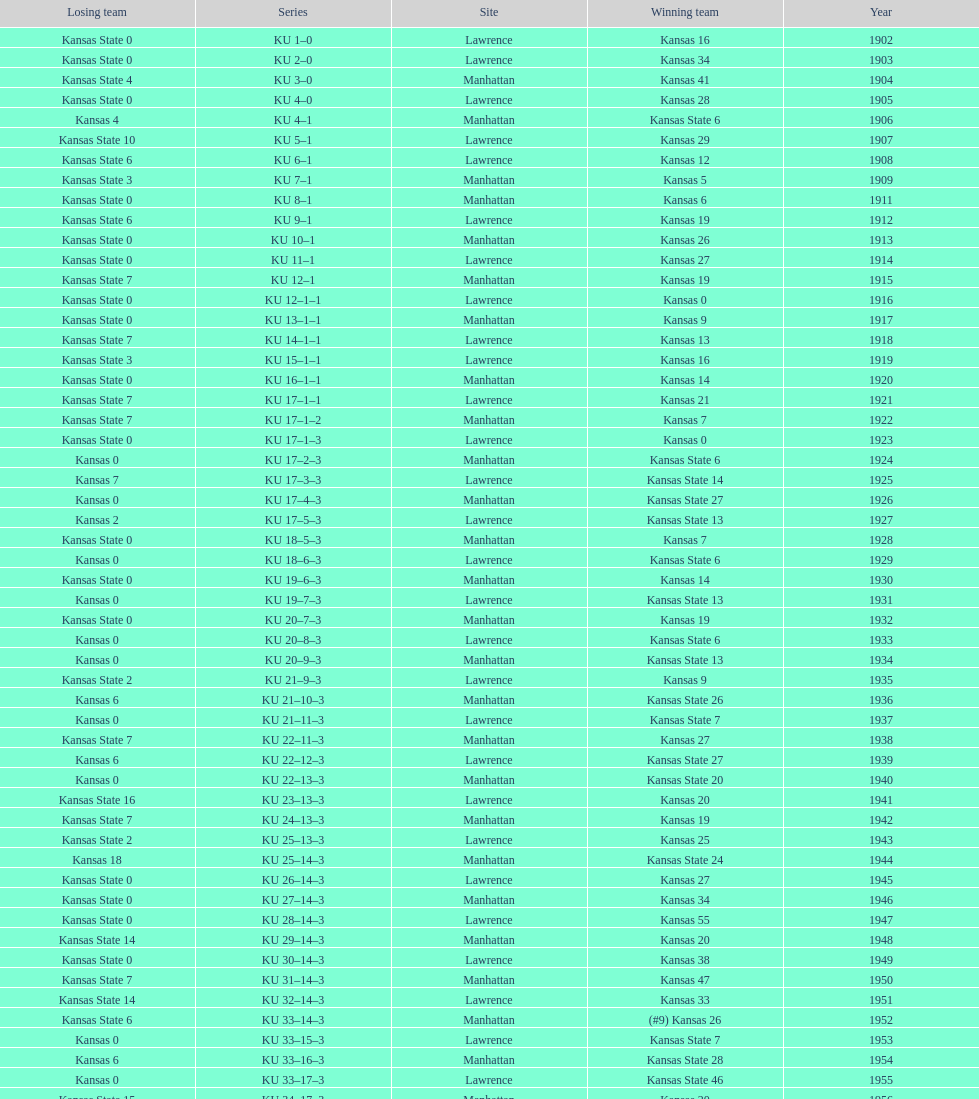When was the last time kansas state lost with 0 points in manhattan? 1964. 